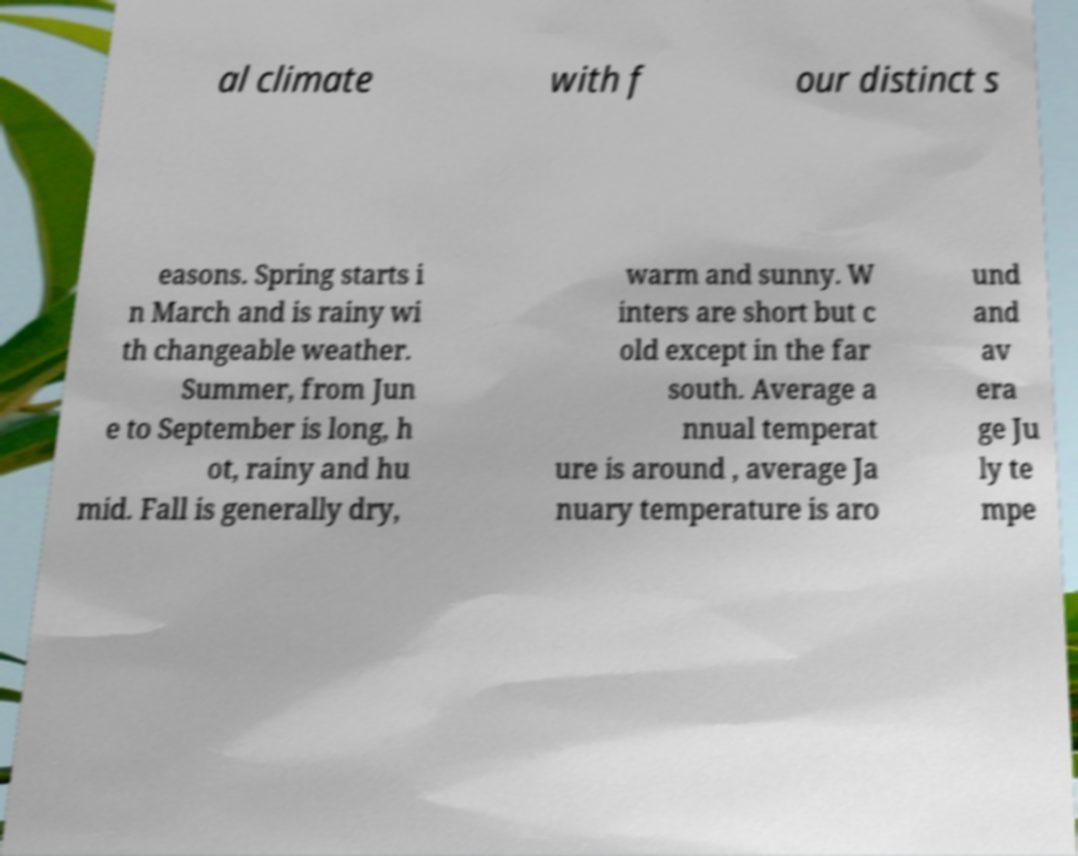There's text embedded in this image that I need extracted. Can you transcribe it verbatim? al climate with f our distinct s easons. Spring starts i n March and is rainy wi th changeable weather. Summer, from Jun e to September is long, h ot, rainy and hu mid. Fall is generally dry, warm and sunny. W inters are short but c old except in the far south. Average a nnual temperat ure is around , average Ja nuary temperature is aro und and av era ge Ju ly te mpe 